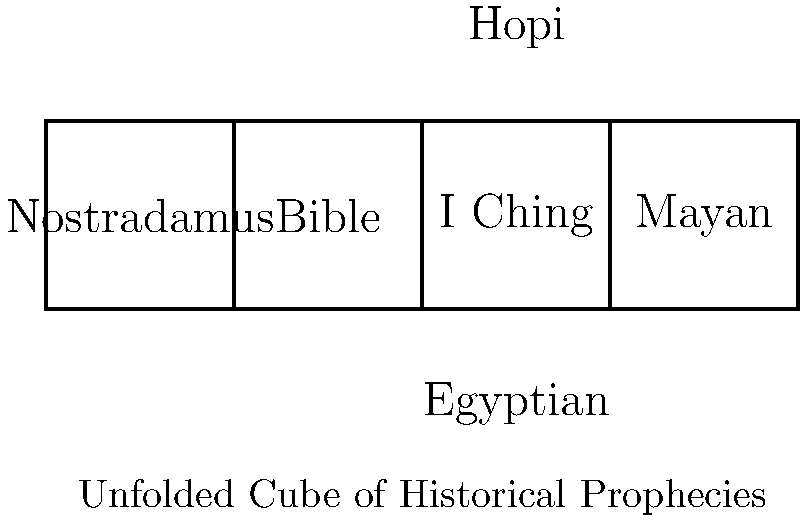As a political science professor studying the impact of historical prophecies on modern policy-making, you encounter an unfolded cube representing different prophetic traditions. Which of the following 3D cube arrangements correctly represents the unfolded shape shown, where opposing faces are: Nostradamus-Mayan, Bible-Hopi, and I Ching-Egyptian? To determine the correct 3D cube arrangement from the unfolded shape, we need to follow these steps:

1. Identify the faces and their relative positions on the unfolded cube:
   - Nostradamus is on the left
   - Bible is in the center-left
   - I Ching is in the center
   - Mayan is in the center-right
   - Hopi is on top
   - Egyptian is on the bottom

2. Understand the opposing face pairs:
   - Nostradamus opposes Mayan
   - Bible opposes Hopi
   - I Ching opposes Egyptian

3. Visualize the folding process:
   - The top face (Hopi) folds down onto the Bible
   - The bottom face (Egyptian) folds up onto the I Ching
   - The left face (Nostradamus) and right face (Mayan) fold inward

4. Consider the final arrangement:
   - Nostradamus and Mayan will be on opposite sides
   - Bible will be on the bottom with Hopi on top
   - I Ching will be on the front with Egyptian on the back

5. The correct 3D cube arrangement would have:
   - Front face: I Ching
   - Back face: Egyptian
   - Top face: Hopi
   - Bottom face: Bible
   - Left face: Nostradamus
   - Right face: Mayan

This arrangement ensures that all opposing face pairs are correctly positioned and the unfolded shape can be reconstructed into a cube.
Answer: Front: I Ching, Back: Egyptian, Top: Hopi, Bottom: Bible, Left: Nostradamus, Right: Mayan 